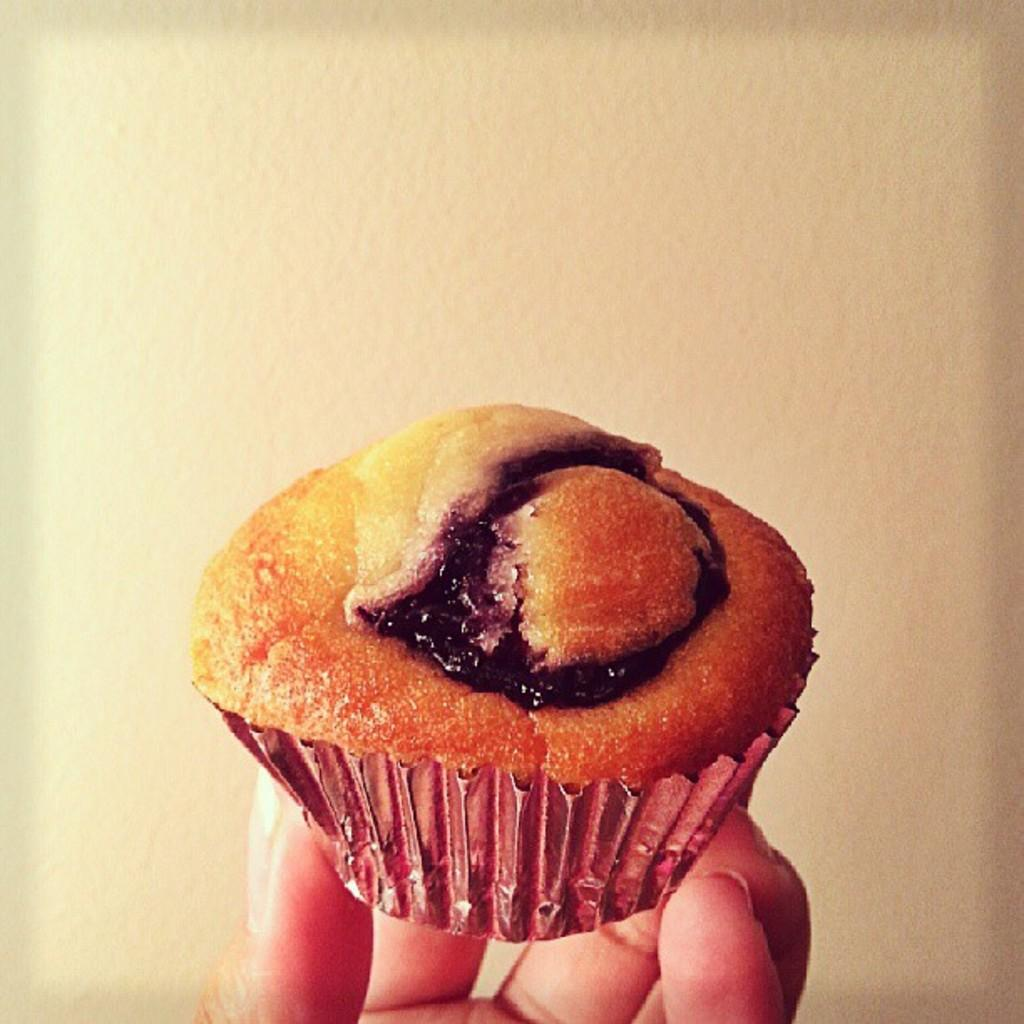What is the person's hand holding in the image? The person's hand is holding a cupcake in the image. What can be seen in the background of the image? There is a wall in the background of the image. Where is the toothbrush located in the image? There is no toothbrush present in the image. What type of garden can be seen in the image? There is no garden present in the image. 